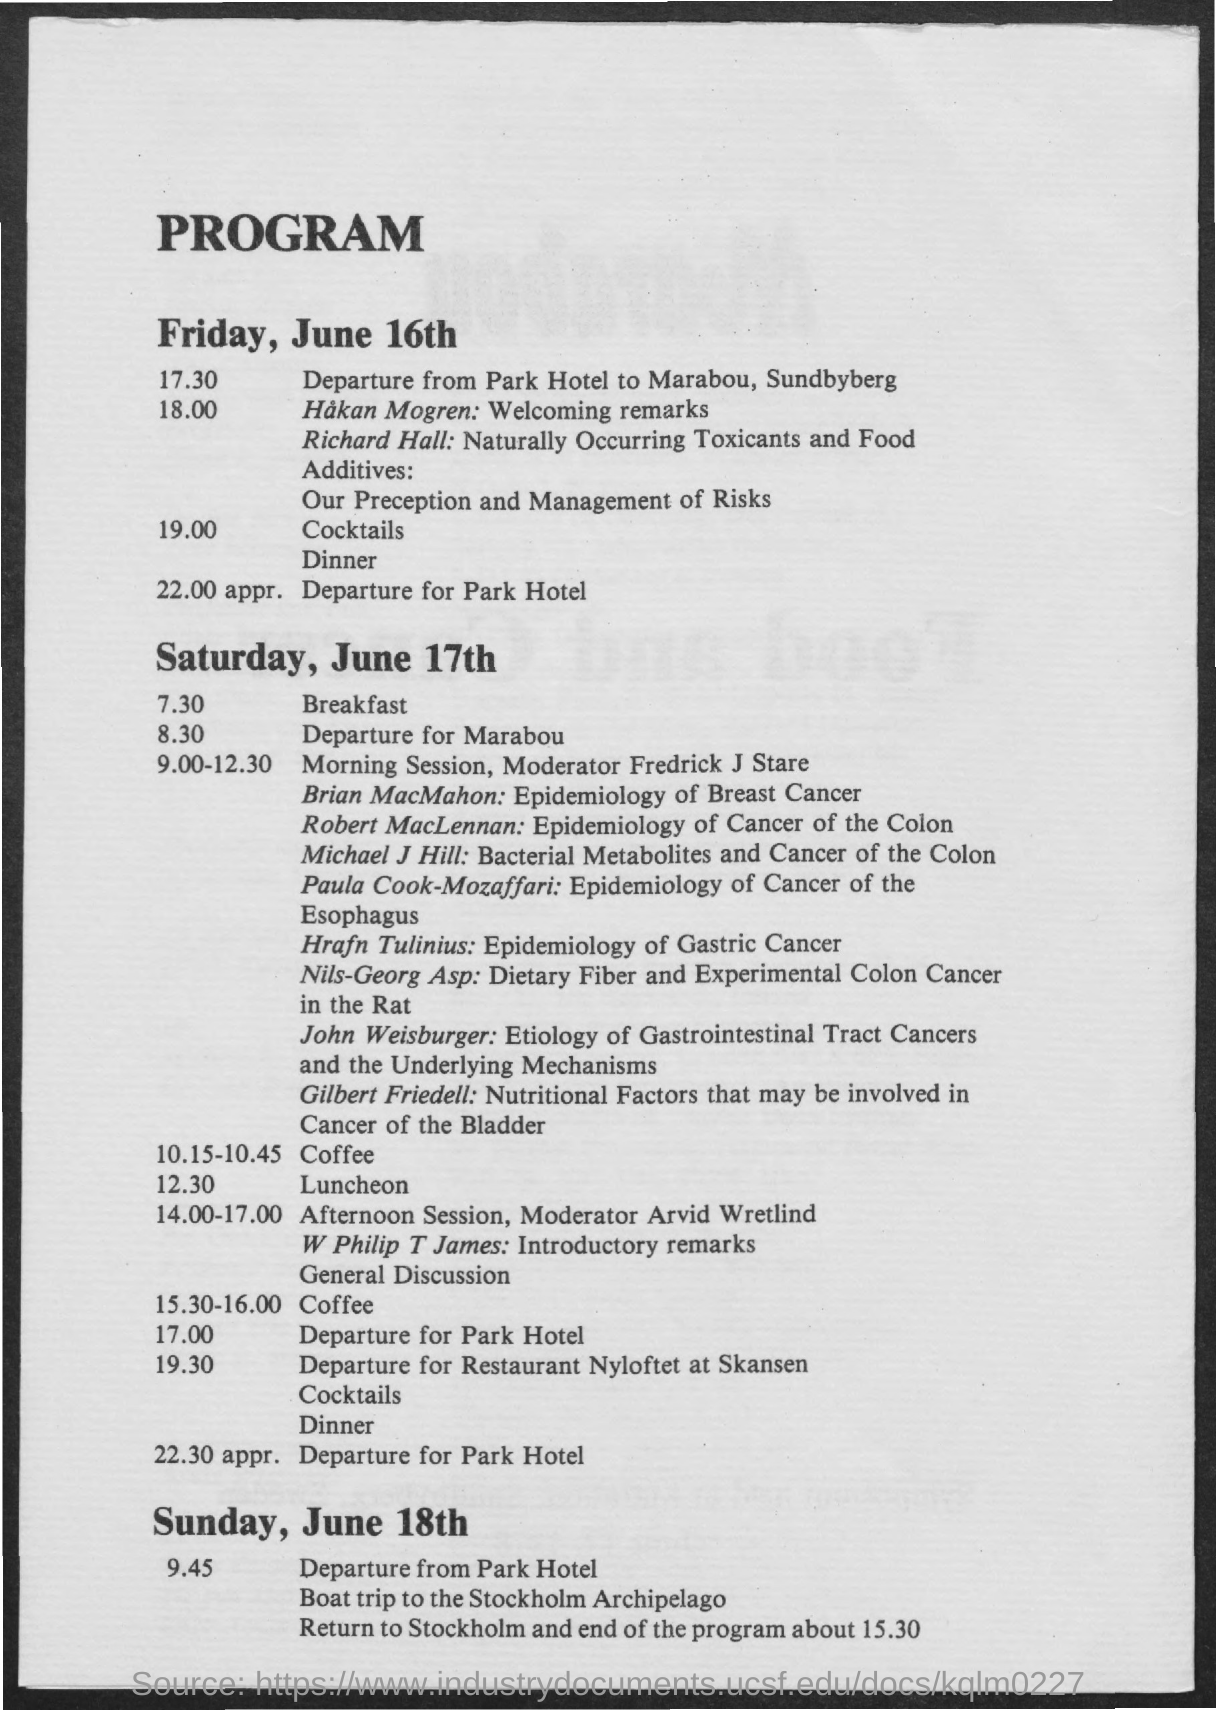Where is the 1st meeting?
Keep it short and to the point. Marabou, Sundbyberg. Who gave Welcoming remarks?
Your answer should be compact. Hakan Mogren. Who discussed Epidemiology of Breast Caner?
Provide a succinct answer. Brian MacMahon. What is the topic of Gilbert Friedell?
Keep it short and to the point. Nutritional Factors that may be involved in Cancer of the Bladder. 